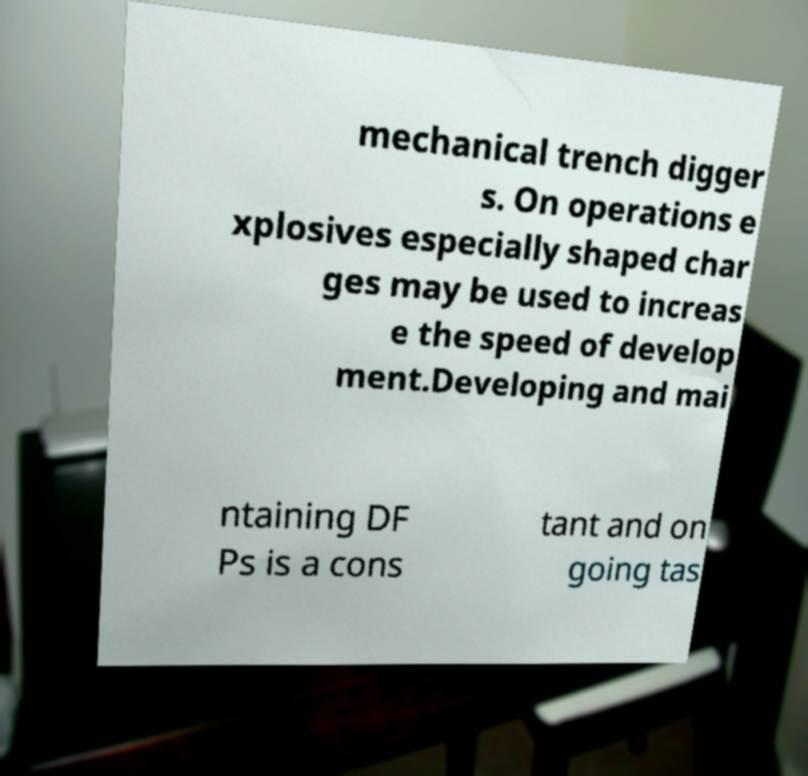I need the written content from this picture converted into text. Can you do that? mechanical trench digger s. On operations e xplosives especially shaped char ges may be used to increas e the speed of develop ment.Developing and mai ntaining DF Ps is a cons tant and on going tas 